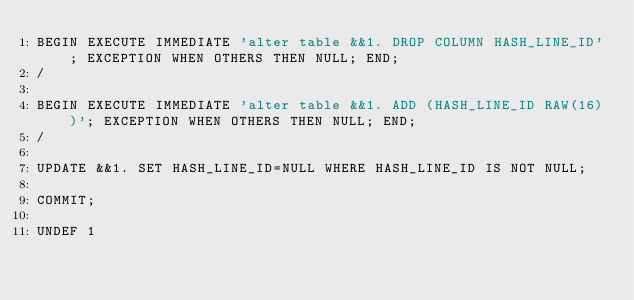Convert code to text. <code><loc_0><loc_0><loc_500><loc_500><_SQL_>BEGIN EXECUTE IMMEDIATE 'alter table &&1. DROP COLUMN HASH_LINE_ID'; EXCEPTION WHEN OTHERS THEN NULL; END;
/

BEGIN EXECUTE IMMEDIATE 'alter table &&1. ADD (HASH_LINE_ID RAW(16))'; EXCEPTION WHEN OTHERS THEN NULL; END;
/

UPDATE &&1. SET HASH_LINE_ID=NULL WHERE HASH_LINE_ID IS NOT NULL;

COMMIT;

UNDEF 1</code> 